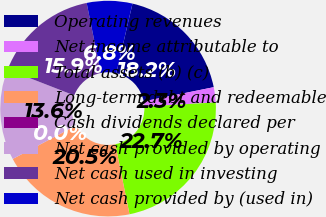Convert chart. <chart><loc_0><loc_0><loc_500><loc_500><pie_chart><fcel>Operating revenues<fcel>Net income attributable to<fcel>Total assets (b) (c)<fcel>Long-term debt and redeemable<fcel>Cash dividends declared per<fcel>Net cash provided by operating<fcel>Net cash used in investing<fcel>Net cash provided by (used in)<nl><fcel>18.18%<fcel>2.27%<fcel>22.73%<fcel>20.45%<fcel>0.0%<fcel>13.64%<fcel>15.91%<fcel>6.82%<nl></chart> 